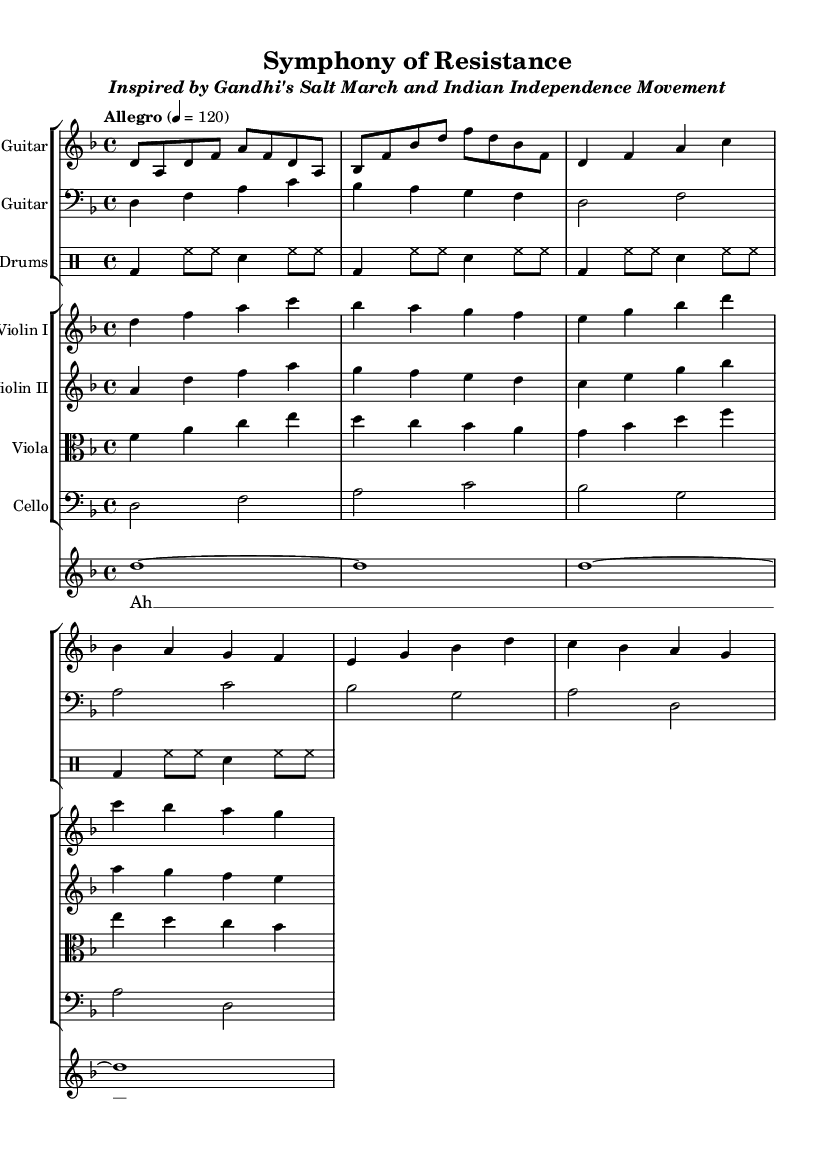What is the time signature of this music? The time signature is located at the beginning of the score and shows 4/4, which indicates four beats in each measure with a quarter note receiving one beat.
Answer: 4/4 What is the key signature of this music? The key signature is found at the beginning of the staff, and in this piece, it shows one flat (B flat), indicating that the piece is in D minor.
Answer: D minor What is the tempo marking for this piece? The tempo marking is indicated with the word "Allegro" followed by a metronome indication of 120 beats per minute, suggesting a lively and fast pace.
Answer: Allegro, 120 What instruments are used in the composition? The instrumental parts listed in the scores include Electric Guitar, Bass Guitar, Drums, Violin I, Violin II, Viola, Cello, and a Choir, all of which contribute to the symphonic metal style.
Answer: Electric Guitar, Bass Guitar, Drums, Violin I, Violin II, Viola, Cello, Choir How many measures are there in the Electric Guitar part? Counting the measures in the Electric Guitar part, there are a total of 8 measures present in the excerpt provided, which outlines the various melodic phrases.
Answer: 8 What is the predominant genre of this composition? The genre is identifiable by the style of instruments and the overall heaviness of the sound typically associated with Symphonic Metal, characterized by orchestral elements blended with metal music.
Answer: Symphonic Metal What historical event inspired this composition? The subtitle of the score "Inspired by Gandhi's Salt March and Indian Independence Movement" reveals that this composition reflects themes of non-violent resistance, specifically drawing from an important historical context.
Answer: Gandhi's Salt March 